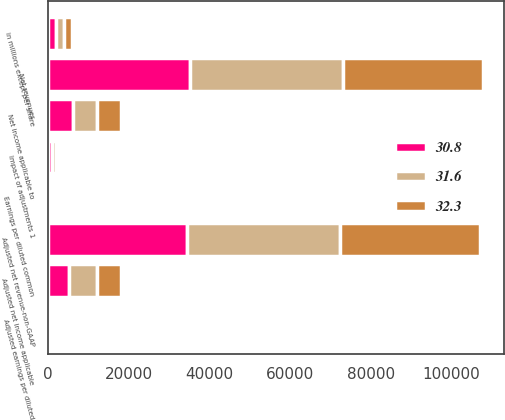Convert chart. <chart><loc_0><loc_0><loc_500><loc_500><stacked_bar_chart><ecel><fcel>in millions except per share<fcel>Net revenues<fcel>Adjusted net revenue-non-GAAP<fcel>Net income applicable to<fcel>Impact of adjustments 1<fcel>Adjusted net income applicable<fcel>Earnings per diluted common<fcel>Adjusted earnings per diluted<nl><fcel>31.6<fcel>2017<fcel>37945<fcel>37945<fcel>6111<fcel>968<fcel>7079<fcel>3.07<fcel>3.6<nl><fcel>32.3<fcel>2016<fcel>34631<fcel>34631<fcel>5979<fcel>68<fcel>5911<fcel>2.92<fcel>2.88<nl><fcel>30.8<fcel>2015<fcel>35155<fcel>34537<fcel>6127<fcel>963<fcel>5164<fcel>2.9<fcel>2.41<nl></chart> 